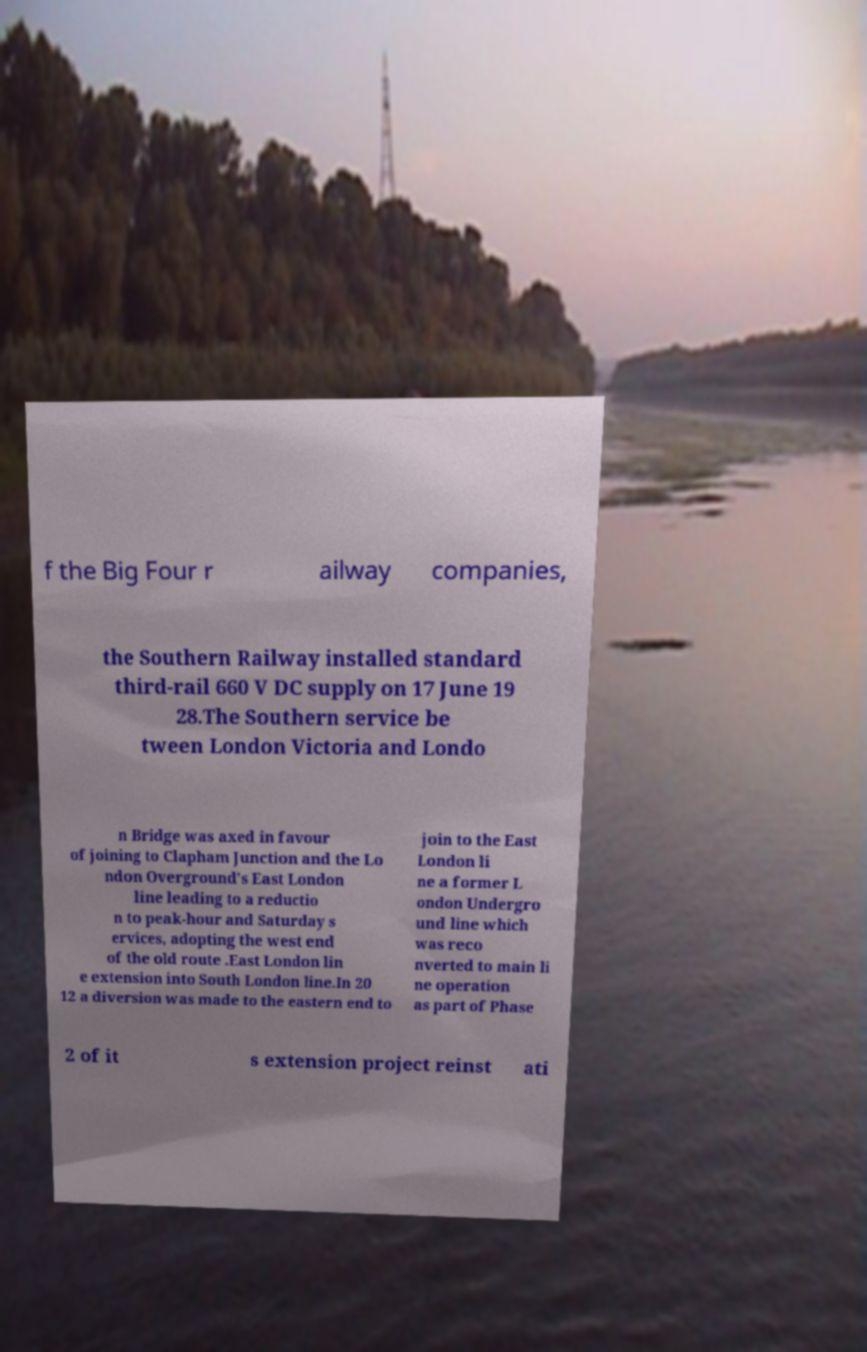What messages or text are displayed in this image? I need them in a readable, typed format. f the Big Four r ailway companies, the Southern Railway installed standard third-rail 660 V DC supply on 17 June 19 28.The Southern service be tween London Victoria and Londo n Bridge was axed in favour of joining to Clapham Junction and the Lo ndon Overground's East London line leading to a reductio n to peak-hour and Saturday s ervices, adopting the west end of the old route .East London lin e extension into South London line.In 20 12 a diversion was made to the eastern end to join to the East London li ne a former L ondon Undergro und line which was reco nverted to main li ne operation as part of Phase 2 of it s extension project reinst ati 